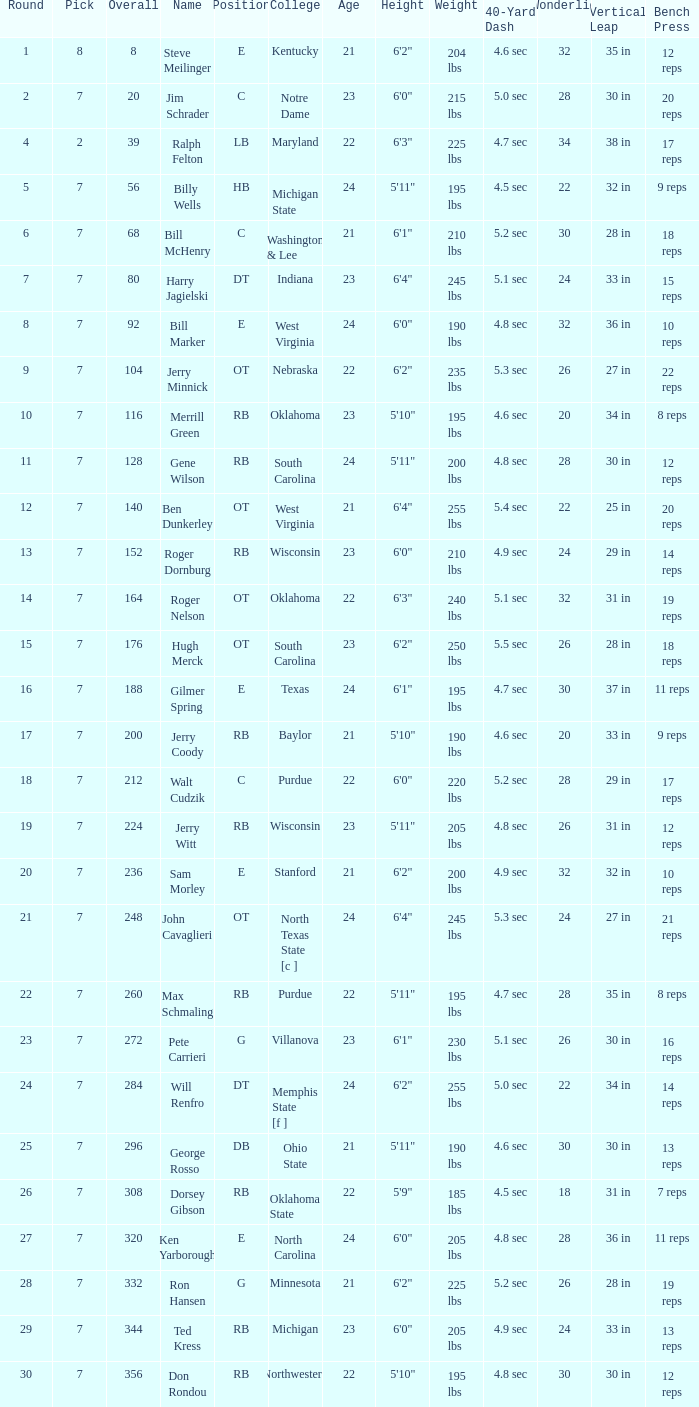What pick did George Rosso get drafted when the overall was less than 296? 0.0. 